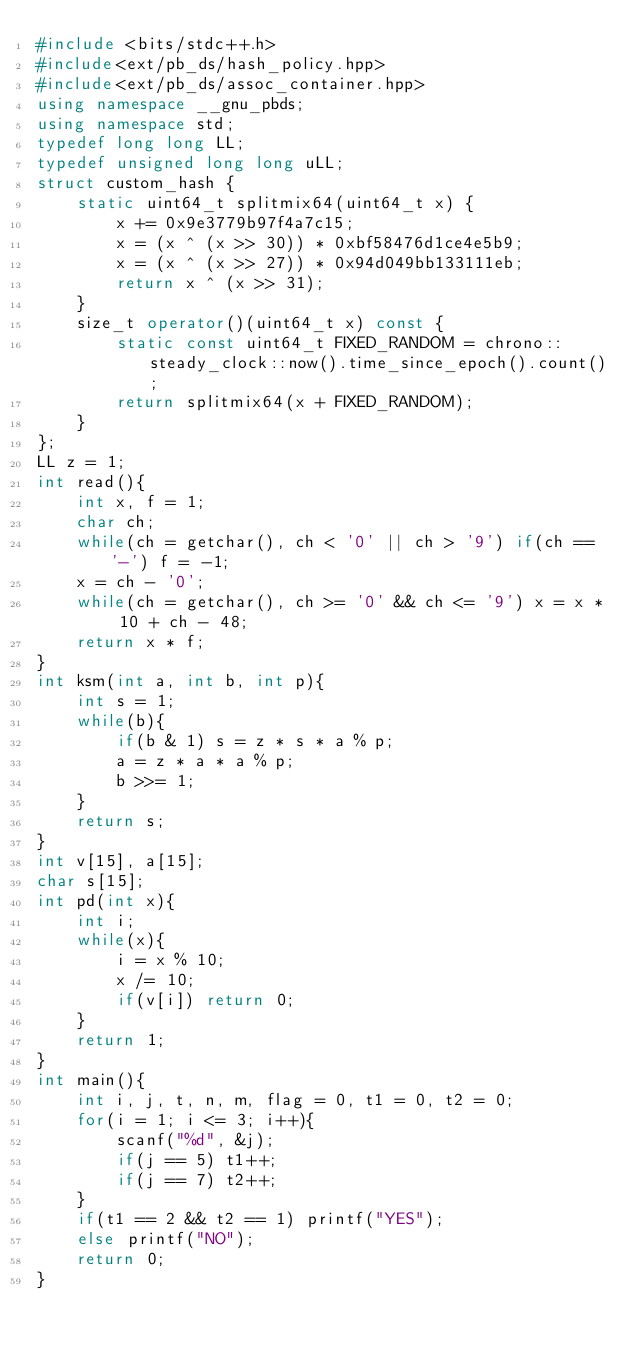Convert code to text. <code><loc_0><loc_0><loc_500><loc_500><_C++_>#include <bits/stdc++.h>
#include<ext/pb_ds/hash_policy.hpp>
#include<ext/pb_ds/assoc_container.hpp>
using namespace __gnu_pbds;
using namespace std;
typedef long long LL;
typedef unsigned long long uLL;
struct custom_hash {
    static uint64_t splitmix64(uint64_t x) {
        x += 0x9e3779b97f4a7c15;
        x = (x ^ (x >> 30)) * 0xbf58476d1ce4e5b9;
        x = (x ^ (x >> 27)) * 0x94d049bb133111eb;
        return x ^ (x >> 31);
    }
    size_t operator()(uint64_t x) const {
        static const uint64_t FIXED_RANDOM = chrono::steady_clock::now().time_since_epoch().count();
        return splitmix64(x + FIXED_RANDOM);
    }
};
LL z = 1;
int read(){
	int x, f = 1;
	char ch;
	while(ch = getchar(), ch < '0' || ch > '9') if(ch == '-') f = -1;
	x = ch - '0';
	while(ch = getchar(), ch >= '0' && ch <= '9') x = x * 10 + ch - 48;
	return x * f;
}
int ksm(int a, int b, int p){
	int s = 1;
	while(b){
		if(b & 1) s = z * s * a % p;
		a = z * a * a % p;
		b >>= 1;
	}
	return s;
}
int v[15], a[15];
char s[15];
int pd(int x){
	int i;
	while(x){
		i = x % 10;
		x /= 10;
		if(v[i]) return 0;
	}
	return 1;
}
int main(){
	int i, j, t, n, m, flag = 0, t1 = 0, t2 = 0;
	for(i = 1; i <= 3; i++){
		scanf("%d", &j);
		if(j == 5) t1++;
		if(j == 7) t2++;
	}
	if(t1 == 2 && t2 == 1) printf("YES");
	else printf("NO");
	return 0;
}
</code> 